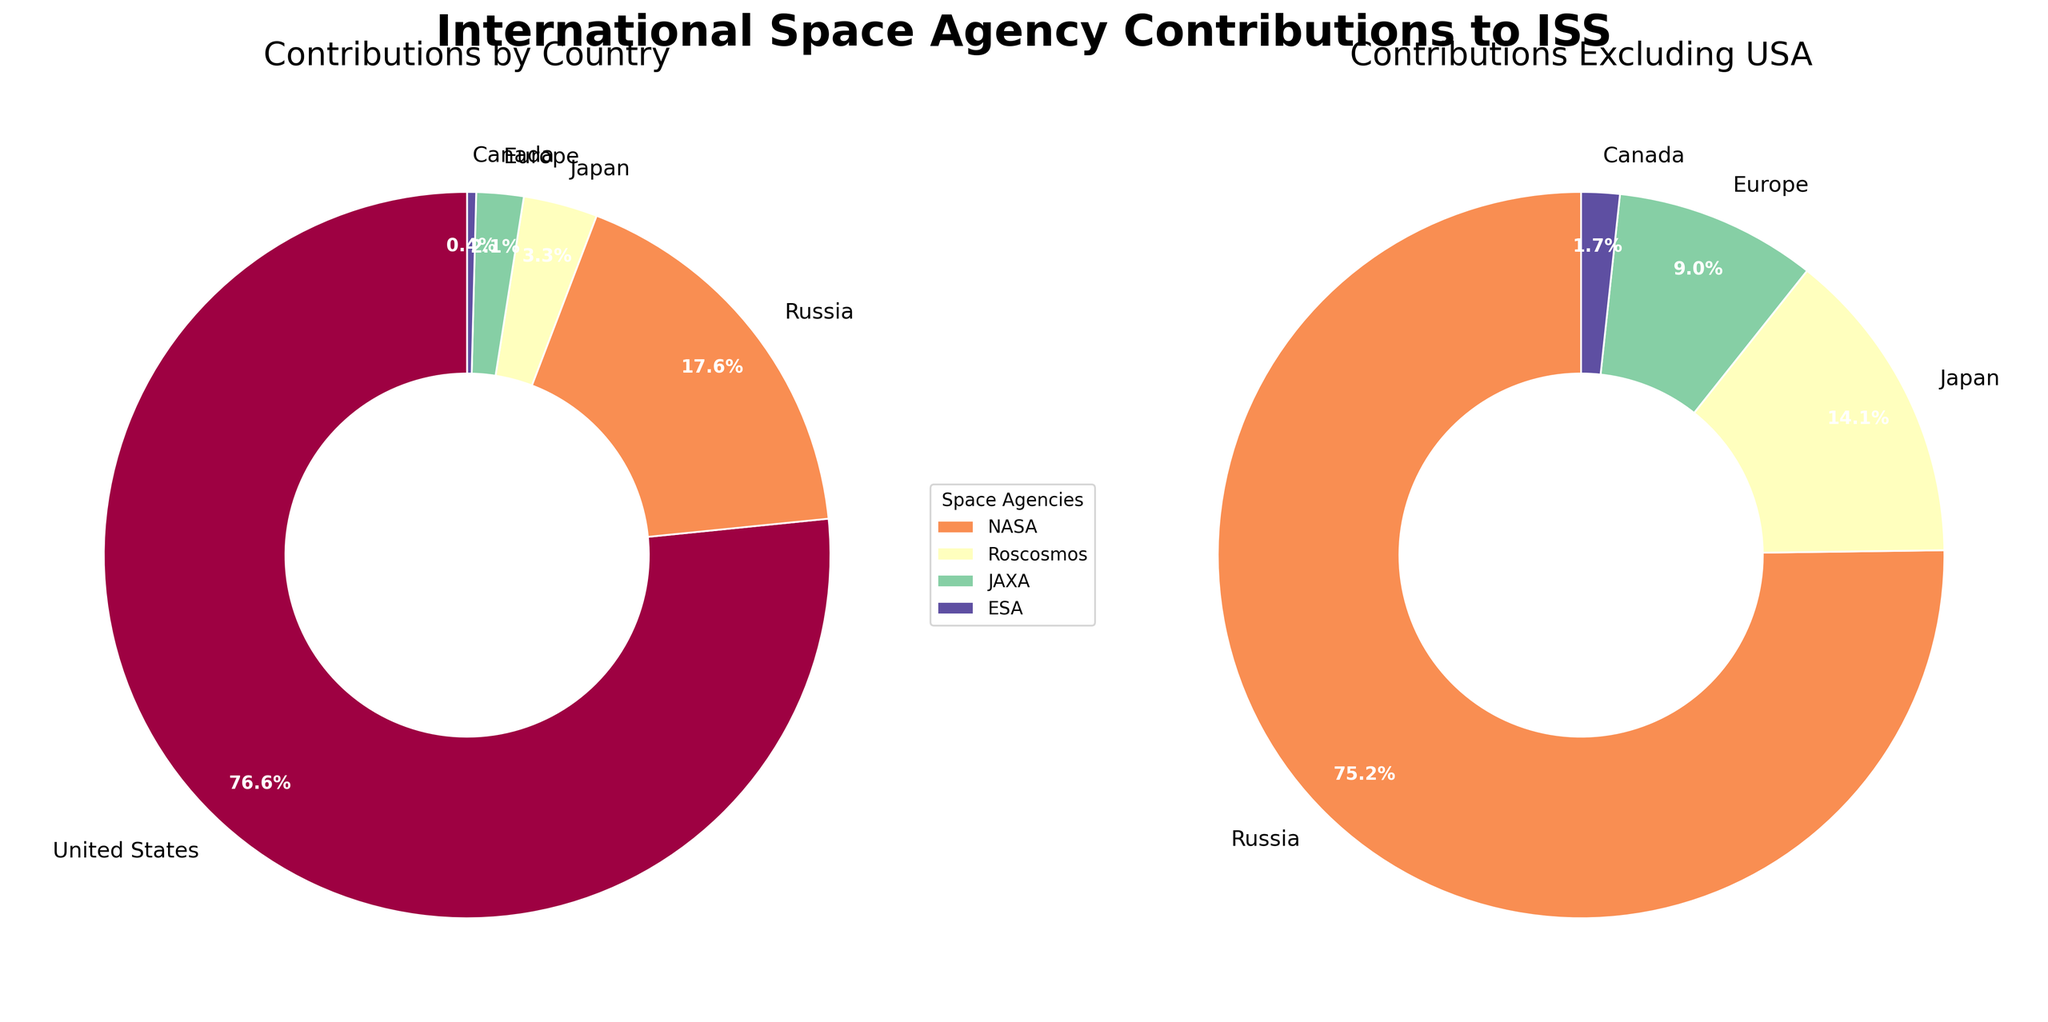Which country has the highest contribution to the ISS? The pie chart for contributions by country shows the United States has the largest share, indicated by the largest wedge.
Answer: United States What is the combined contribution of Russia and Japan? From the contributions by country, Russia contributes 17.6% and Japan 3.3%. Adding these gives 17.6 + 3.3 = 20.9%.
Answer: 20.9% Which country has the smallest contribution to the ISS? The pie chart for contributions by country shows the smallest wedge belongs to Canada.
Answer: Canada What is the percentage contribution of Europe excluding the United States? The contributions excluding the USA pie chart shows Europe's contribution as 2.1%. This value is directly read off the chart.
Answer: 2.1% Compare the contributions of Roscosmos and ESA. Which is larger and by how much? From the contributions by country, Roscosmos contributes 17.6% and ESA 2.1%. The difference is 17.6 - 2.1 = 15.5%.
Answer: Roscosmos by 15.5% How many countries contribute to the ISS? The pie chart for contributions by country shows five different wedges, each representing a country.
Answer: 5 What is the total contribution of countries other than the United States? The contributions by countries other than the United States are shown in the second pie chart. Adding these contributions gives 17.6 (Russia) + 3.3 (Japan) + 2.1 (Europe) + 0.4 (Canada) = 23.4%.
Answer: 23.4% Which two countries together make up more than 90% of the total contribution to the ISS? From the contributions by country, the United States contributes 76.6% and Russia 17.6%. Together, 76.6 + 17.6 = 94.2%, which is more than 90%.
Answer: United States and Russia What is the combined contribution of Canada, Japan, and Europe? From the contributions by country, combining these values gives 0.4 (Canada) + 3.3 (Japan) + 2.1 (Europe) = 5.8%.
Answer: 5.8% What visual elements differentiate the contributions by country and excluding USA pie charts? The contributions by country chart includes all five countries, while the excluding USA chart only includes Russia, Japan, Europe, and Canada. Both use different color palettes for clear distinction.
Answer: All countries vs. excluding USA 